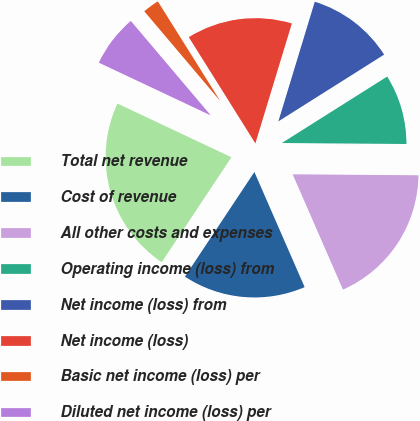<chart> <loc_0><loc_0><loc_500><loc_500><pie_chart><fcel>Total net revenue<fcel>Cost of revenue<fcel>All other costs and expenses<fcel>Operating income (loss) from<fcel>Net income (loss) from<fcel>Net income (loss)<fcel>Basic net income (loss) per<fcel>Diluted net income (loss) per<nl><fcel>22.68%<fcel>15.88%<fcel>18.33%<fcel>9.08%<fcel>11.34%<fcel>13.61%<fcel>2.27%<fcel>6.81%<nl></chart> 